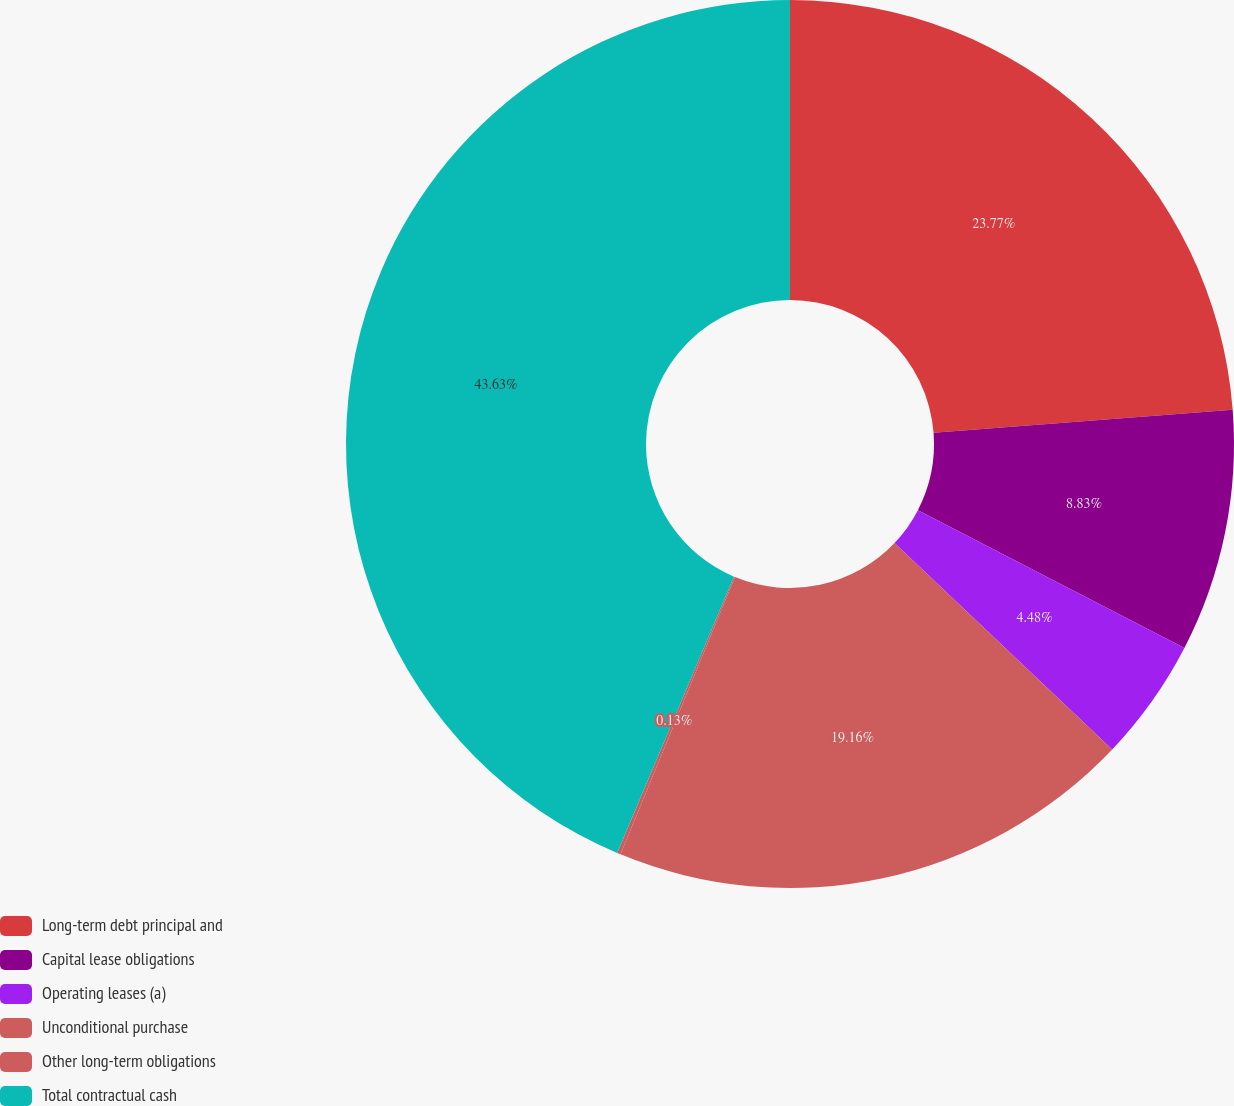<chart> <loc_0><loc_0><loc_500><loc_500><pie_chart><fcel>Long-term debt principal and<fcel>Capital lease obligations<fcel>Operating leases (a)<fcel>Unconditional purchase<fcel>Other long-term obligations<fcel>Total contractual cash<nl><fcel>23.77%<fcel>8.83%<fcel>4.48%<fcel>19.16%<fcel>0.13%<fcel>43.64%<nl></chart> 